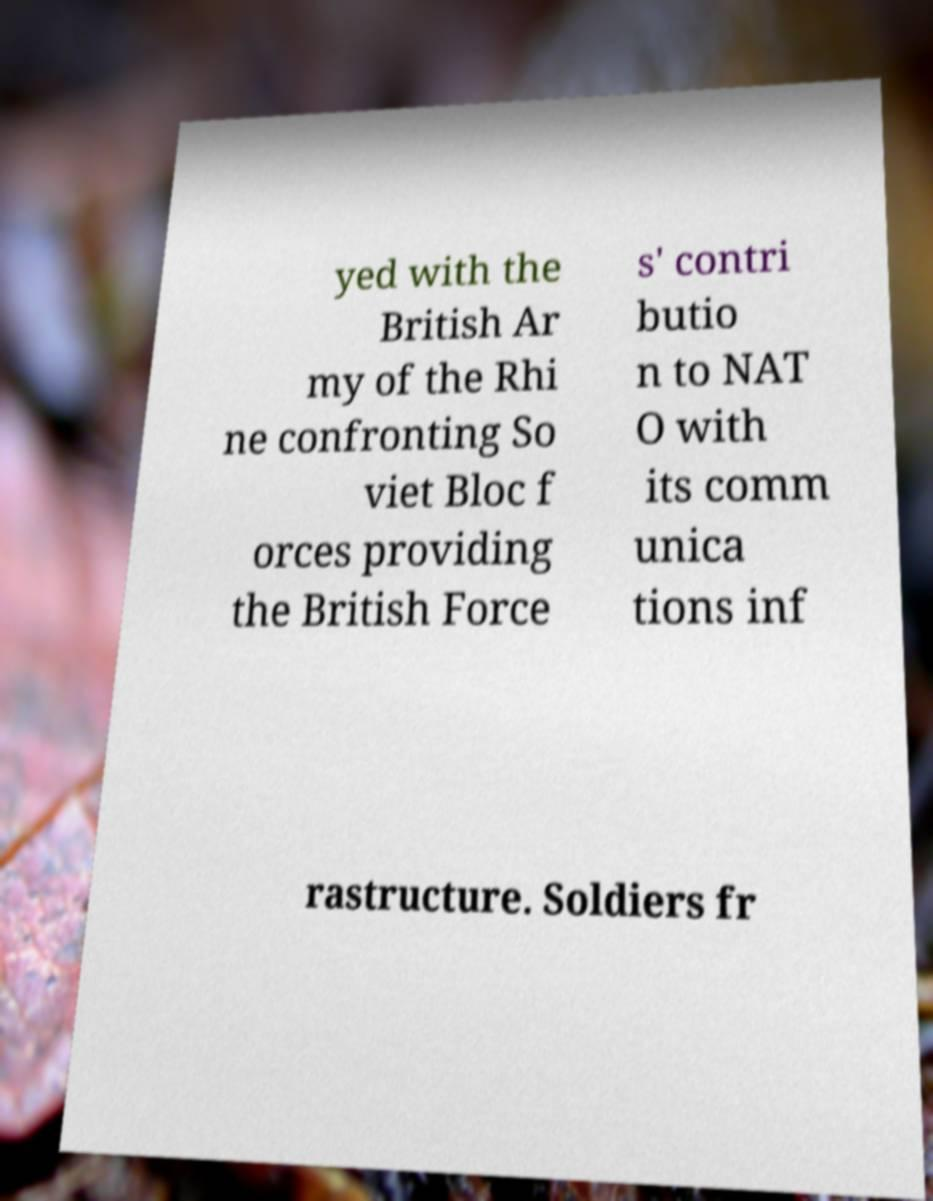For documentation purposes, I need the text within this image transcribed. Could you provide that? yed with the British Ar my of the Rhi ne confronting So viet Bloc f orces providing the British Force s' contri butio n to NAT O with its comm unica tions inf rastructure. Soldiers fr 